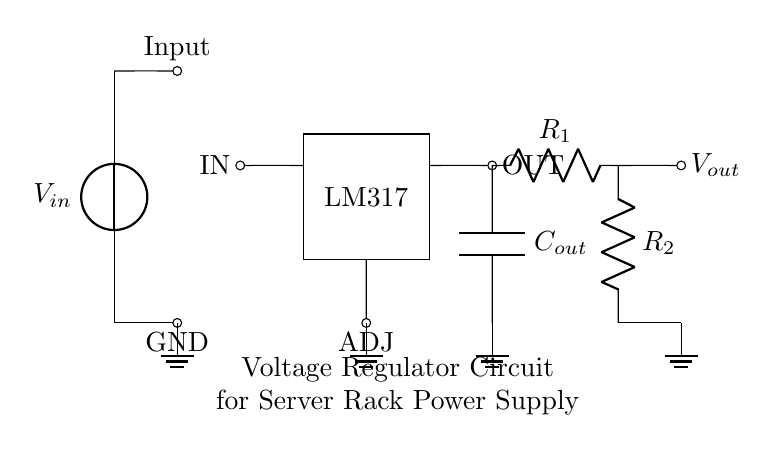What is the input component of the circuit? The circuit contains a voltage source labeled input, which is the first component encountered.
Answer: Voltage source What type of voltage regulator is used in this circuit? The rectangle labeled with the name indicates that an LM317 voltage regulator IC is used in the circuit design.
Answer: LM317 What are the values of R1 and R2? The circuit diagram does not provide specific numerical values for the resistors, but they are both labeled as R1 and R2.
Answer: R1 and R2 What is the function of Cout in the circuit? The capacitor labeled Cout is connected to the output; its function is typically to stabilize the output voltage and filter any noise.
Answer: Stabilizing output Why is the adjustment pin important in this circuit? The adjustment pin (ADJ) is crucial for adjustable regulators like LM317, allowing the user to set the output voltage by adjusting the resistance values of R1 and R2.
Answer: Output voltage adjustment What type of circuit is represented here? The arrangement of components indicates that this is a voltage regulation circuit designed to maintain stability and quality of the power supply in server racks.
Answer: Voltage regulator circuit Where is the output voltage taken from in the circuit? The output voltage is taken from the right side of the LM317 regulator, where it connects to the resistor R1 leading to the output node.
Answer: Right side 